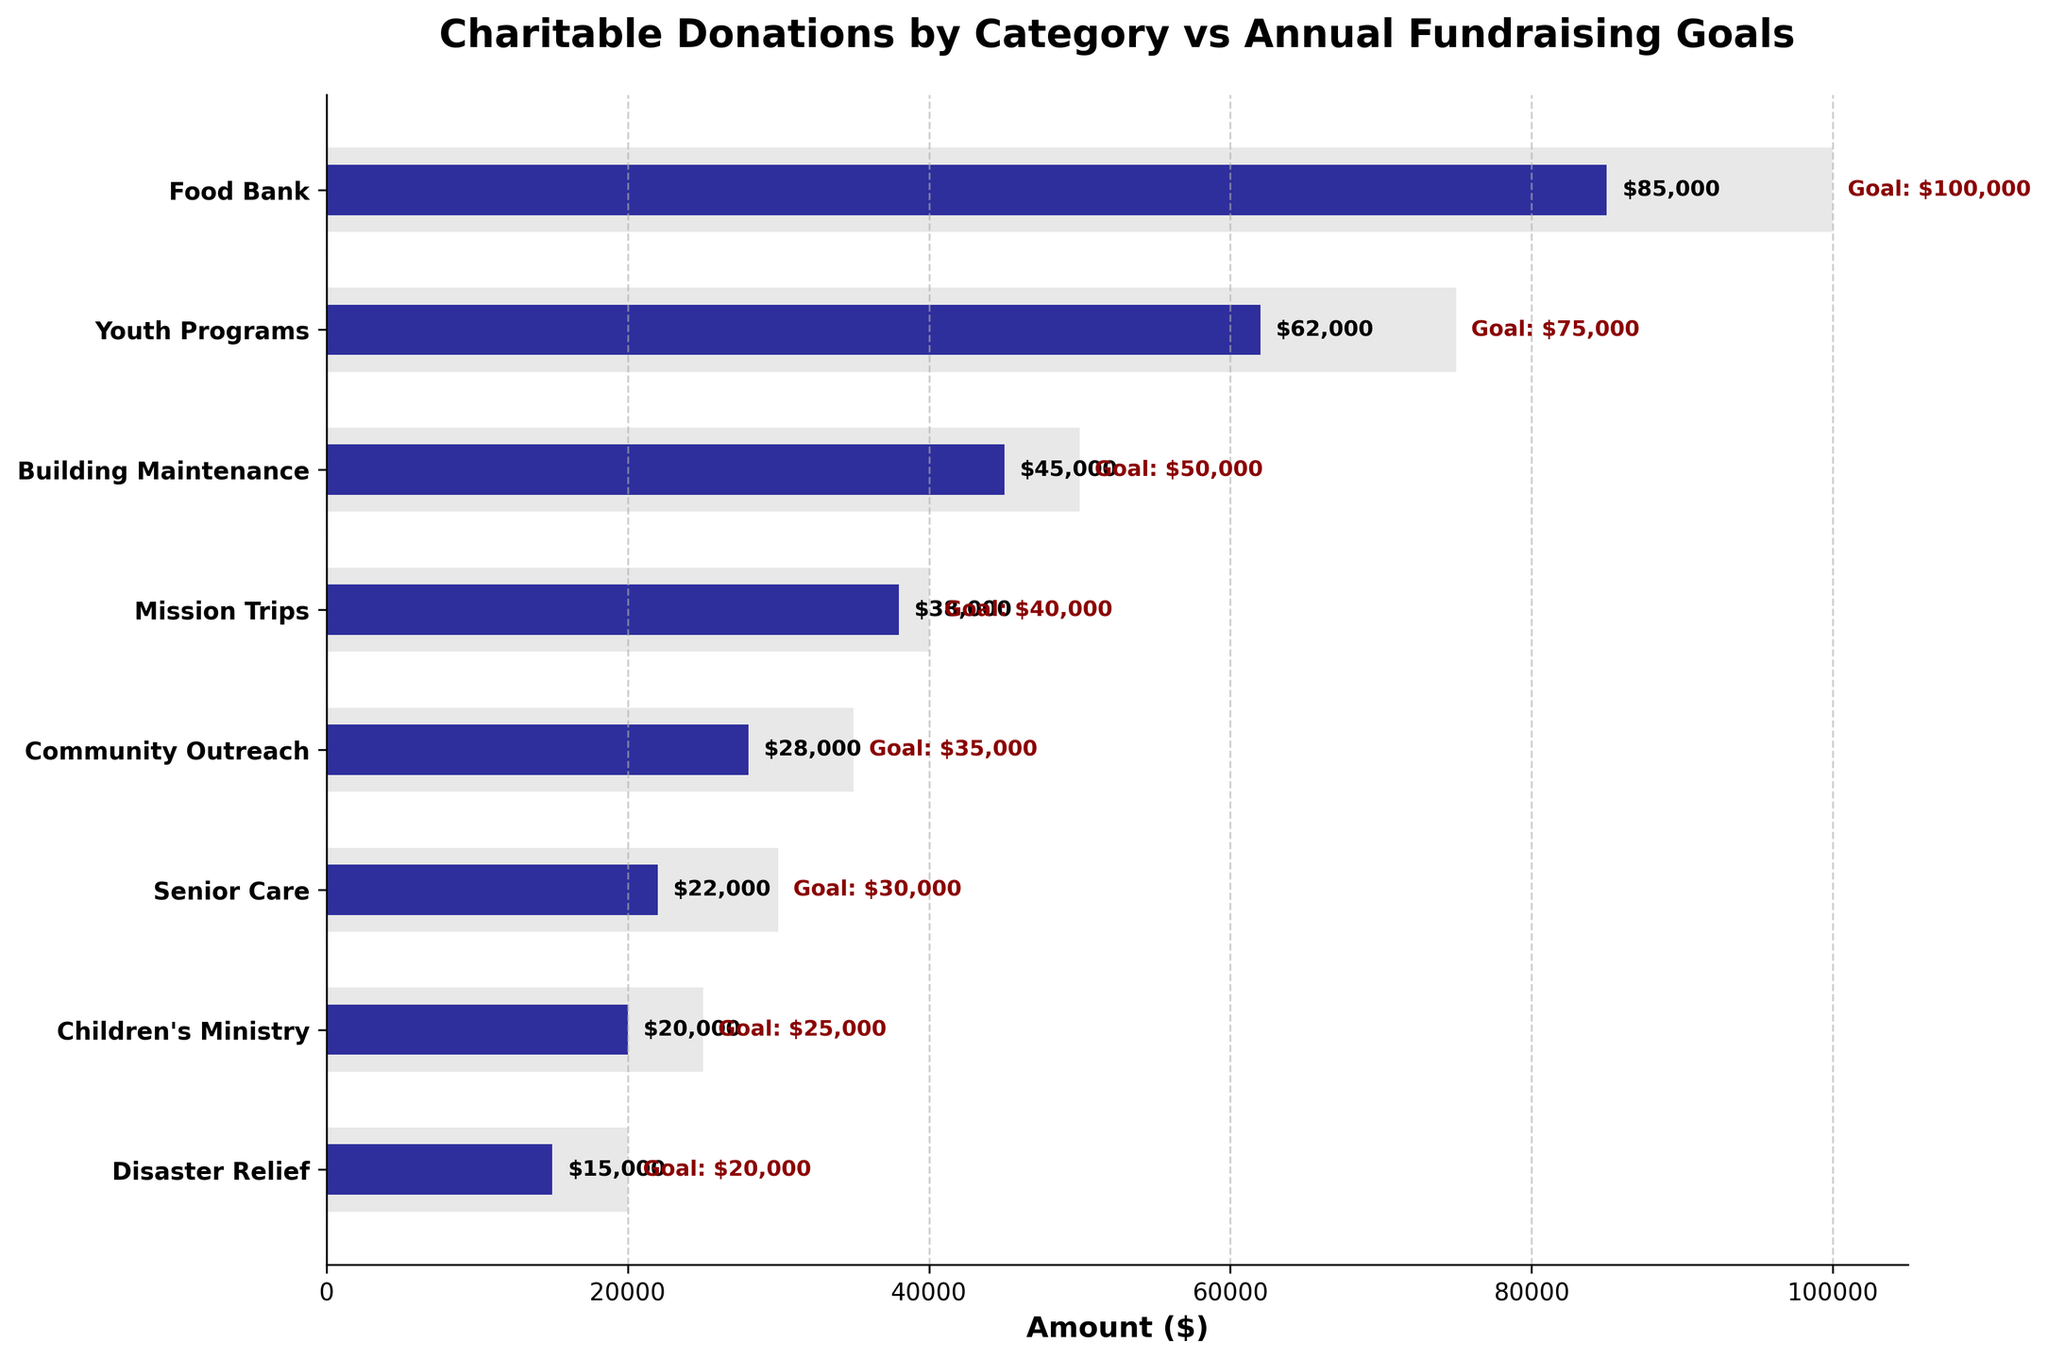What is the title of the chart? The title is prominently shown at the top of the chart.
Answer: Charitable Donations by Category vs Annual Fundraising Goals How many categories are displayed on the chart? By counting the number of horizontal bars, each representing a category.
Answer: 8 Which category has the highest fundraising goal? By looking at the length of the light gray bars, which represent the goals.
Answer: Food Bank How much more is needed to reach the goal for Mission Trips? The goal for Mission Trips is $40,000, while the actual amount raised is $38,000. $40,000 - $38,000 = $2,000.
Answer: $2,000 Which categories have not yet achieved their fundraising goals? Compare the length of the dark blue bars (actuals) with the light gray bars (goals). Categories like Food Bank, Youth Programs, Building Maintenance, Mission Trips, Community Outreach, Senior Care, Children's Ministry, and Disaster Relief have not reached their goals.
Answer: Food Bank, Youth Programs, Building Maintenance, Mission Trips, Community Outreach, Senior Care, Children's Ministry, Disaster Relief How much total has been raised across all categories? Sum the actual donations: $85,000 + $62,000 + $45,000 + $38,000 + $28,000 + $22,000 + $20,000 + $15,000 = $315,000.
Answer: $315,000 Which category has the smallest gap between the actual amount raised and the goal? Calculate the differences for each: 
- Food Bank: $100,000 - $85,000 = $15,000
- Youth Programs: $75,000 - $62,000 = $13,000
- Building Maintenance: $50,000 - $45,000 = $5,000
- Mission Trips: $40,000 - $38,000 = $2,000
- Community Outreach: $35,000 - $28,000 = $7,000
- Senior Care: $30,000 - $22,000 = $8,000
- Children's Ministry: $25,000 - $20,000 = $5,000
- Disaster Relief: $20,000 - $15,000 = $5,000. The smallest gap is $2,000 for Mission Trips.
Answer: Mission Trips What percentage of the goal has been achieved for Community Outreach? Use the formula (actual/goal) * 100 = percentage. For Community Outreach, ($28,000 / $35,000) * 100 ≈ 80%.
Answer: 80% What is the difference in the amount raised between Disaster Relief and Children's Ministry? Subtract the actual amount of Disaster Relief from Children's Ministry: $20,000 - $15,000 = $5,000.
Answer: $5,000 Which category has raised more, Senior Care or Youth Programs? By comparing the actual amounts: Senior Care has raised $22,000, and Youth Programs have raised $62,000. Youth Programs have raised more.
Answer: Youth Programs 